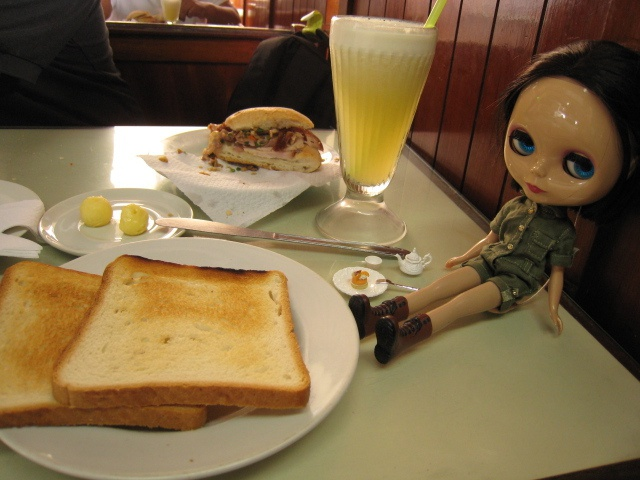Describe the objects in this image and their specific colors. I can see dining table in black, tan, and olive tones, cup in black, tan, and olive tones, people in black, maroon, and gray tones, dining table in black, maroon, and gray tones, and sandwich in black, olive, maroon, and tan tones in this image. 